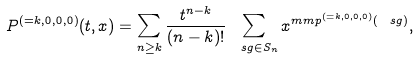<formula> <loc_0><loc_0><loc_500><loc_500>P ^ { ( = k , 0 , 0 , 0 ) } ( t , x ) = \sum _ { n \geq k } \frac { t ^ { n - k } } { ( n - k ) ! } \sum _ { \ s g \in S _ { n } } x ^ { m m p ^ { ( = k , 0 , 0 , 0 ) } ( \ s g ) } ,</formula> 